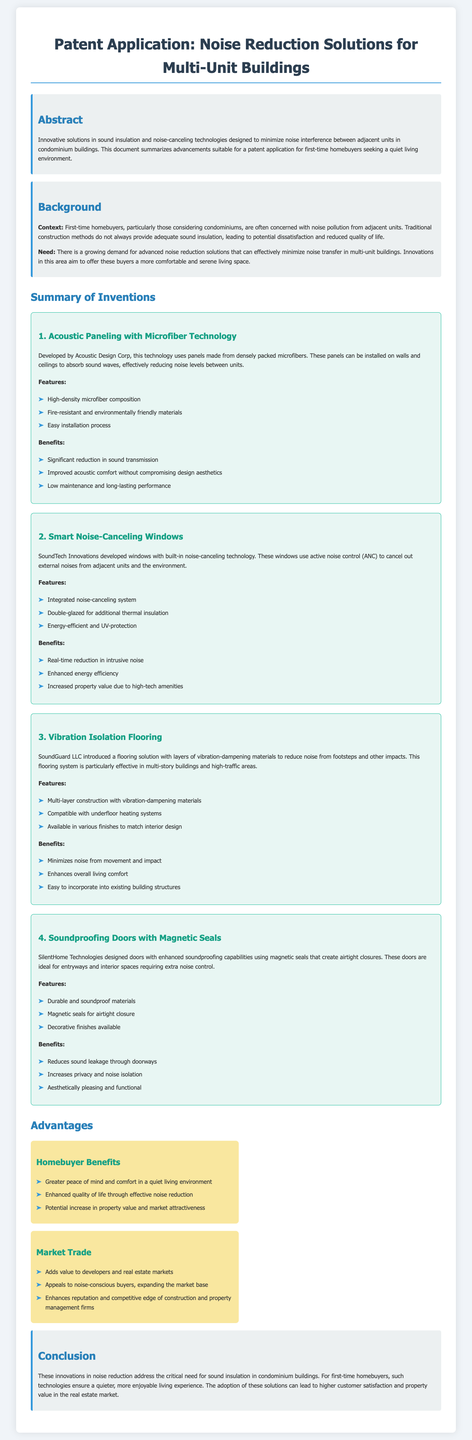What is the main focus of the patent application? The patent application focuses on innovative solutions for minimizing noise interference in condominium buildings.
Answer: noise reduction solutions What company developed the acoustic paneling technology? The company behind the acoustic paneling technology is mentioned in the document as Acoustic Design Corp.
Answer: Acoustic Design Corp What feature do smart noise-canceling windows have? The smart noise-canceling windows have an integrated noise-canceling system.
Answer: integrated noise-canceling system What is the benefit of vibration isolation flooring? One benefit of vibration isolation flooring is that it minimizes noise from movement and impact.
Answer: minimizes noise from movement and impact What kind of seals do soundproofing doors use? The soundproofing doors use magnetic seals for airtight closure.
Answer: magnetic seals What are the homebuyer benefits listed in the document? Homebuyer benefits include greater peace of mind and comfort in a quiet living environment.
Answer: greater peace of mind and comfort What type of technology is used in the second invention? The second invention utilizes active noise control technology.
Answer: active noise control What is a key market advantage mentioned in the document? A key market advantage mentioned is that it adds value to developers and real estate markets.
Answer: adds value to developers and real estate markets What type of application is this document? This document is a patent application aimed at innovations for noise reduction.
Answer: patent application 